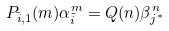<formula> <loc_0><loc_0><loc_500><loc_500>P _ { \tilde { i } , 1 } ( m ) \alpha _ { \tilde { i } } ^ { m } = Q ( n ) \beta _ { j ^ { * } } ^ { n }</formula> 